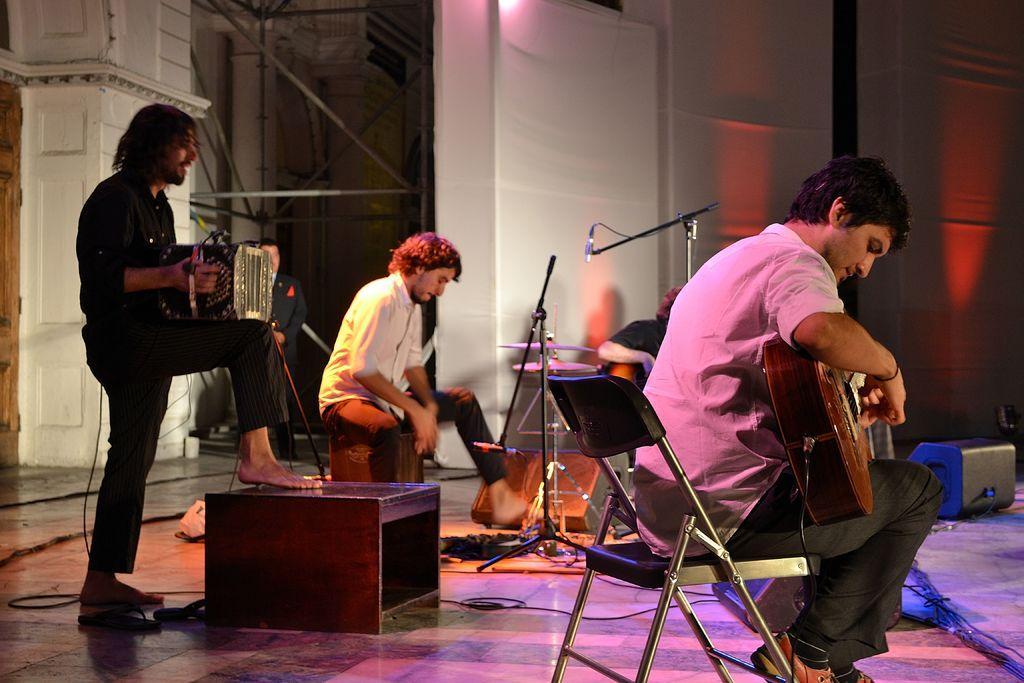In one or two sentences, can you explain what this image depicts? In the center of the picture there is a band performing on the stage. In the foreground there is a person playing guitar sitting on a chair. On the left the person is playing a musical instrument. In the background there are drums and microphones. In the background there are iron poles and wall painted white. 